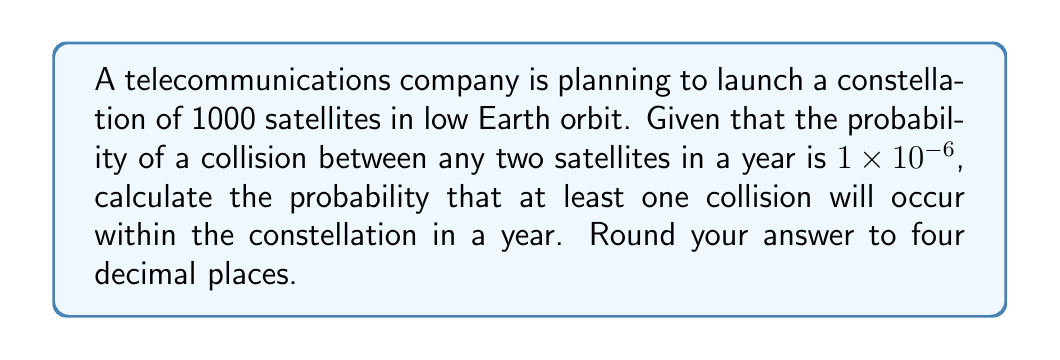Show me your answer to this math problem. To solve this problem, we'll use the complement of the probability that no collisions occur. Let's break it down step-by-step:

1) First, we need to calculate the total number of possible satellite pairs. With 1000 satellites, the number of pairs is:

   $$\binom{1000}{2} = \frac{1000!}{2!(1000-2)!} = \frac{1000 \times 999}{2} = 499,500$$

2) The probability of no collision between a specific pair of satellites is:

   $$1 - (1 \times 10^{-6}) = 0.999999$$

3) For no collisions to occur at all, we need this to be true for all 499,500 pairs. The probability of this is:

   $$(0.999999)^{499,500}$$

4) Therefore, the probability of at least one collision is the complement of this:

   $$1 - (0.999999)^{499,500}$$

5) Let's calculate this:

   $$\begin{align}
   1 - (0.999999)^{499,500} &= 1 - e^{499,500 \times \ln(0.999999)} \\
   &= 1 - e^{499,500 \times (-0.000001)} \\
   &= 1 - e^{-0.4995} \\
   &= 1 - 0.6069 \\
   &= 0.3931
   \end{align}$$

6) Rounding to four decimal places:

   $$0.3931 \approx 0.3931$$
Answer: 0.3931 